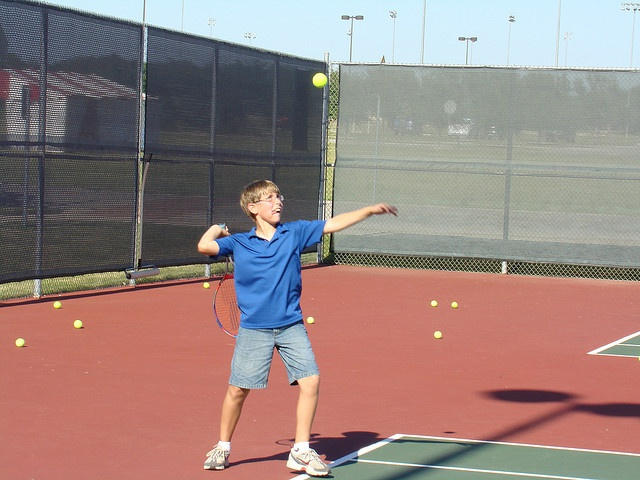Describe the objects in this image and their specific colors. I can see people in black, gray, blue, tan, and darkgray tones, tennis racket in black, salmon, brown, and gray tones, sports ball in black, khaki, yellow, lightyellow, and olive tones, sports ball in navy, khaki, salmon, and lightyellow tones, and sports ball in black, khaki, yellow, and tan tones in this image. 